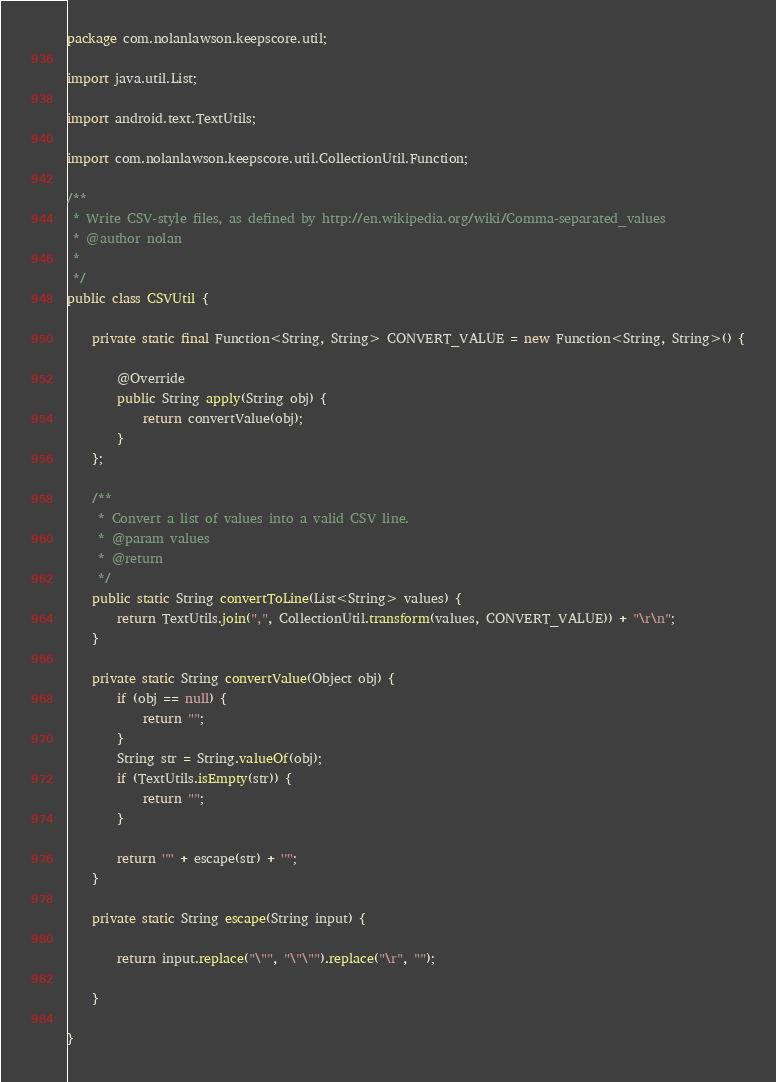Convert code to text. <code><loc_0><loc_0><loc_500><loc_500><_Java_>package com.nolanlawson.keepscore.util;

import java.util.List;

import android.text.TextUtils;

import com.nolanlawson.keepscore.util.CollectionUtil.Function;

/**
 * Write CSV-style files, as defined by http://en.wikipedia.org/wiki/Comma-separated_values
 * @author nolan
 *
 */
public class CSVUtil {

    private static final Function<String, String> CONVERT_VALUE = new Function<String, String>() {

        @Override
        public String apply(String obj) {
            return convertValue(obj);
        }
    };
    
    /**
     * Convert a list of values into a valid CSV line.
     * @param values
     * @return
     */
    public static String convertToLine(List<String> values) {
        return TextUtils.join(",", CollectionUtil.transform(values, CONVERT_VALUE)) + "\r\n";
    }
    
    private static String convertValue(Object obj) {
        if (obj == null) {
            return "";
        }
        String str = String.valueOf(obj);
        if (TextUtils.isEmpty(str)) {
            return "";
        }
        
        return '"' + escape(str) + '"';
    }
    
    private static String escape(String input) {
        
        return input.replace("\"", "\"\"").replace("\r", "");
        
    }
    
}
</code> 